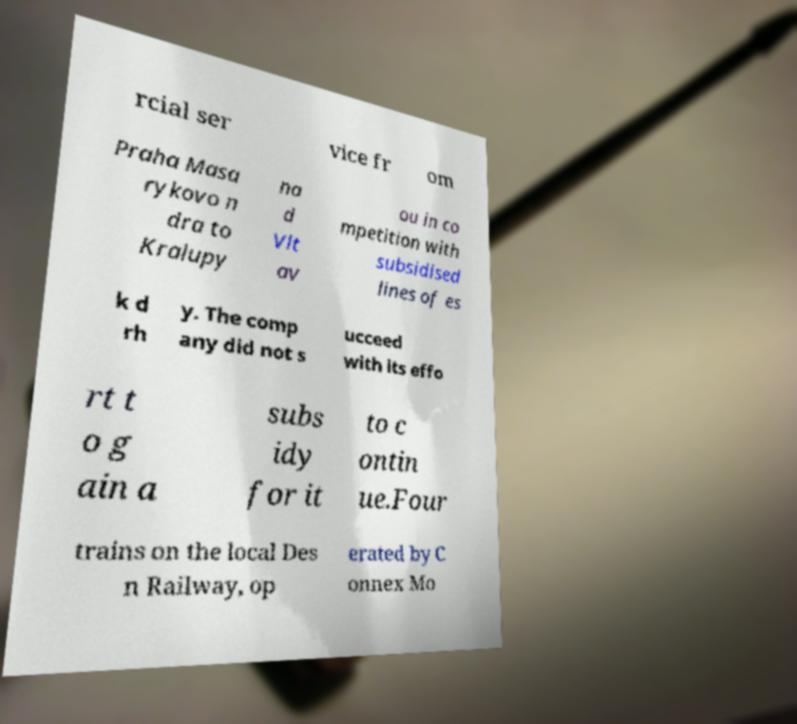For documentation purposes, I need the text within this image transcribed. Could you provide that? rcial ser vice fr om Praha Masa rykovo n dra to Kralupy na d Vlt av ou in co mpetition with subsidised lines of es k d rh y. The comp any did not s ucceed with its effo rt t o g ain a subs idy for it to c ontin ue.Four trains on the local Des n Railway, op erated by C onnex Mo 